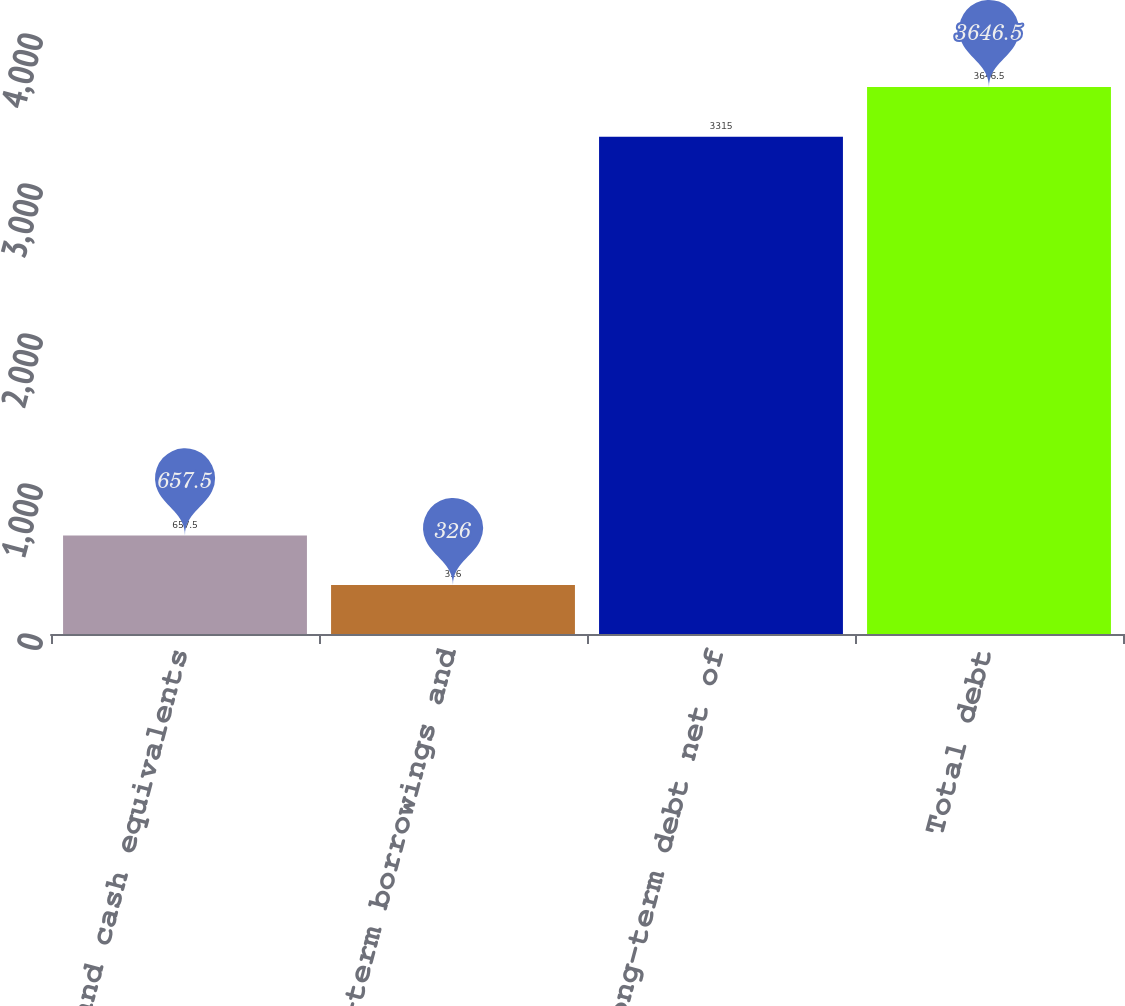<chart> <loc_0><loc_0><loc_500><loc_500><bar_chart><fcel>Cash and cash equivalents<fcel>Short-term borrowings and<fcel>Long-term debt net of<fcel>Total debt<nl><fcel>657.5<fcel>326<fcel>3315<fcel>3646.5<nl></chart> 